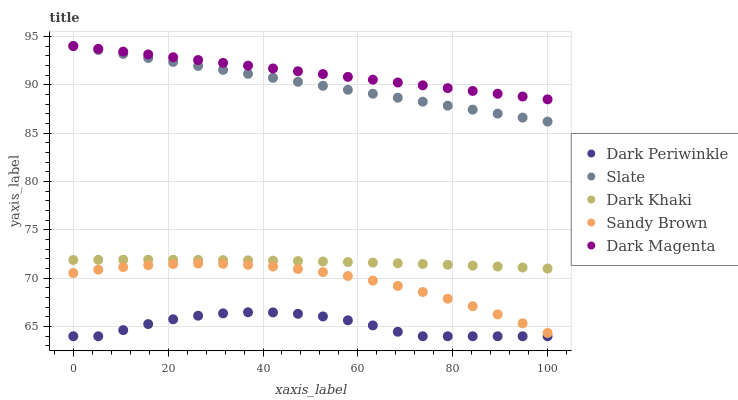Does Dark Periwinkle have the minimum area under the curve?
Answer yes or no. Yes. Does Dark Magenta have the maximum area under the curve?
Answer yes or no. Yes. Does Slate have the minimum area under the curve?
Answer yes or no. No. Does Slate have the maximum area under the curve?
Answer yes or no. No. Is Slate the smoothest?
Answer yes or no. Yes. Is Dark Periwinkle the roughest?
Answer yes or no. Yes. Is Sandy Brown the smoothest?
Answer yes or no. No. Is Sandy Brown the roughest?
Answer yes or no. No. Does Dark Periwinkle have the lowest value?
Answer yes or no. Yes. Does Slate have the lowest value?
Answer yes or no. No. Does Dark Magenta have the highest value?
Answer yes or no. Yes. Does Sandy Brown have the highest value?
Answer yes or no. No. Is Dark Periwinkle less than Dark Khaki?
Answer yes or no. Yes. Is Dark Khaki greater than Sandy Brown?
Answer yes or no. Yes. Does Slate intersect Dark Magenta?
Answer yes or no. Yes. Is Slate less than Dark Magenta?
Answer yes or no. No. Is Slate greater than Dark Magenta?
Answer yes or no. No. Does Dark Periwinkle intersect Dark Khaki?
Answer yes or no. No. 